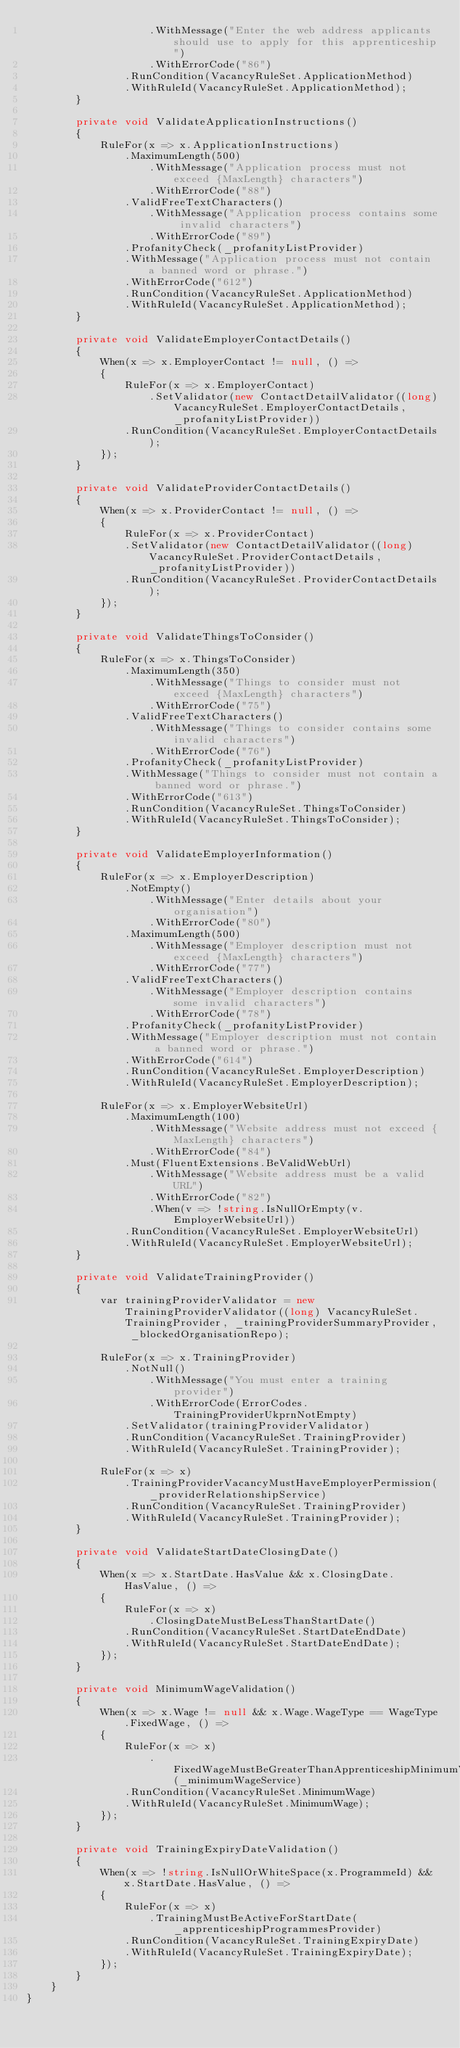<code> <loc_0><loc_0><loc_500><loc_500><_C#_>                    .WithMessage("Enter the web address applicants should use to apply for this apprenticeship")
                    .WithErrorCode("86")
                .RunCondition(VacancyRuleSet.ApplicationMethod)
                .WithRuleId(VacancyRuleSet.ApplicationMethod);
        }

        private void ValidateApplicationInstructions()
        {
            RuleFor(x => x.ApplicationInstructions)
                .MaximumLength(500)
                    .WithMessage("Application process must not exceed {MaxLength} characters")
                    .WithErrorCode("88")
                .ValidFreeTextCharacters()
                    .WithMessage("Application process contains some invalid characters")
                    .WithErrorCode("89")
                .ProfanityCheck(_profanityListProvider)
                .WithMessage("Application process must not contain a banned word or phrase.")
                .WithErrorCode("612")
                .RunCondition(VacancyRuleSet.ApplicationMethod)
                .WithRuleId(VacancyRuleSet.ApplicationMethod);
        }

        private void ValidateEmployerContactDetails()
        {
            When(x => x.EmployerContact != null, () =>
            {
                RuleFor(x => x.EmployerContact)
                    .SetValidator(new ContactDetailValidator((long)VacancyRuleSet.EmployerContactDetails,_profanityListProvider))
                .RunCondition(VacancyRuleSet.EmployerContactDetails);
            });
        }

        private void ValidateProviderContactDetails()
        {
            When(x => x.ProviderContact != null, () =>
            {
                RuleFor(x => x.ProviderContact)
                .SetValidator(new ContactDetailValidator((long)VacancyRuleSet.ProviderContactDetails,_profanityListProvider))
                .RunCondition(VacancyRuleSet.ProviderContactDetails);
            });
        }

        private void ValidateThingsToConsider()
        {
            RuleFor(x => x.ThingsToConsider)
                .MaximumLength(350)
                    .WithMessage("Things to consider must not exceed {MaxLength} characters")
                    .WithErrorCode("75")
                .ValidFreeTextCharacters()
                    .WithMessage("Things to consider contains some invalid characters")
                    .WithErrorCode("76")
                .ProfanityCheck(_profanityListProvider)
                .WithMessage("Things to consider must not contain a banned word or phrase.")
                .WithErrorCode("613")
                .RunCondition(VacancyRuleSet.ThingsToConsider)
                .WithRuleId(VacancyRuleSet.ThingsToConsider);
        }

        private void ValidateEmployerInformation()
        {
            RuleFor(x => x.EmployerDescription)
                .NotEmpty()
                    .WithMessage("Enter details about your organisation")
                    .WithErrorCode("80")
                .MaximumLength(500)
                    .WithMessage("Employer description must not exceed {MaxLength} characters")
                    .WithErrorCode("77")
                .ValidFreeTextCharacters()
                    .WithMessage("Employer description contains some invalid characters")
                    .WithErrorCode("78")
                .ProfanityCheck(_profanityListProvider)
                .WithMessage("Employer description must not contain a banned word or phrase.")
                .WithErrorCode("614")
                .RunCondition(VacancyRuleSet.EmployerDescription)
                .WithRuleId(VacancyRuleSet.EmployerDescription);

            RuleFor(x => x.EmployerWebsiteUrl)
                .MaximumLength(100)
                    .WithMessage("Website address must not exceed {MaxLength} characters")
                    .WithErrorCode("84")
                .Must(FluentExtensions.BeValidWebUrl)
                    .WithMessage("Website address must be a valid URL")
                    .WithErrorCode("82")
                    .When(v => !string.IsNullOrEmpty(v.EmployerWebsiteUrl))
                .RunCondition(VacancyRuleSet.EmployerWebsiteUrl)
                .WithRuleId(VacancyRuleSet.EmployerWebsiteUrl);
        }

        private void ValidateTrainingProvider()
        {
            var trainingProviderValidator = new TrainingProviderValidator((long) VacancyRuleSet.TrainingProvider, _trainingProviderSummaryProvider, _blockedOrganisationRepo);

            RuleFor(x => x.TrainingProvider)
                .NotNull()
                    .WithMessage("You must enter a training provider")
                    .WithErrorCode(ErrorCodes.TrainingProviderUkprnNotEmpty)
                .SetValidator(trainingProviderValidator)
                .RunCondition(VacancyRuleSet.TrainingProvider)
                .WithRuleId(VacancyRuleSet.TrainingProvider);

            RuleFor(x => x)
                .TrainingProviderVacancyMustHaveEmployerPermission(_providerRelationshipService)
                .RunCondition(VacancyRuleSet.TrainingProvider)
                .WithRuleId(VacancyRuleSet.TrainingProvider);
        }

        private void ValidateStartDateClosingDate()
        {
            When(x => x.StartDate.HasValue && x.ClosingDate.HasValue, () =>
            {
                RuleFor(x => x)
                    .ClosingDateMustBeLessThanStartDate()
                .RunCondition(VacancyRuleSet.StartDateEndDate)
                .WithRuleId(VacancyRuleSet.StartDateEndDate);
            });
        }

        private void MinimumWageValidation()
        {
            When(x => x.Wage != null && x.Wage.WageType == WageType.FixedWage, () =>
            {
                RuleFor(x => x)
                    .FixedWageMustBeGreaterThanApprenticeshipMinimumWage(_minimumWageService)
                .RunCondition(VacancyRuleSet.MinimumWage)
                .WithRuleId(VacancyRuleSet.MinimumWage);
            });
        }

        private void TrainingExpiryDateValidation()
        {
            When(x => !string.IsNullOrWhiteSpace(x.ProgrammeId) && x.StartDate.HasValue, () =>
            {
                RuleFor(x => x)
                    .TrainingMustBeActiveForStartDate(_apprenticeshipProgrammesProvider)
                .RunCondition(VacancyRuleSet.TrainingExpiryDate)
                .WithRuleId(VacancyRuleSet.TrainingExpiryDate);
            });
        }
    }
}
</code> 